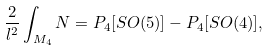Convert formula to latex. <formula><loc_0><loc_0><loc_500><loc_500>\frac { 2 } { l ^ { 2 } } \int _ { M _ { 4 } } N = P _ { 4 } [ S O ( 5 ) ] - P _ { 4 } [ S O ( 4 ) ] ,</formula> 